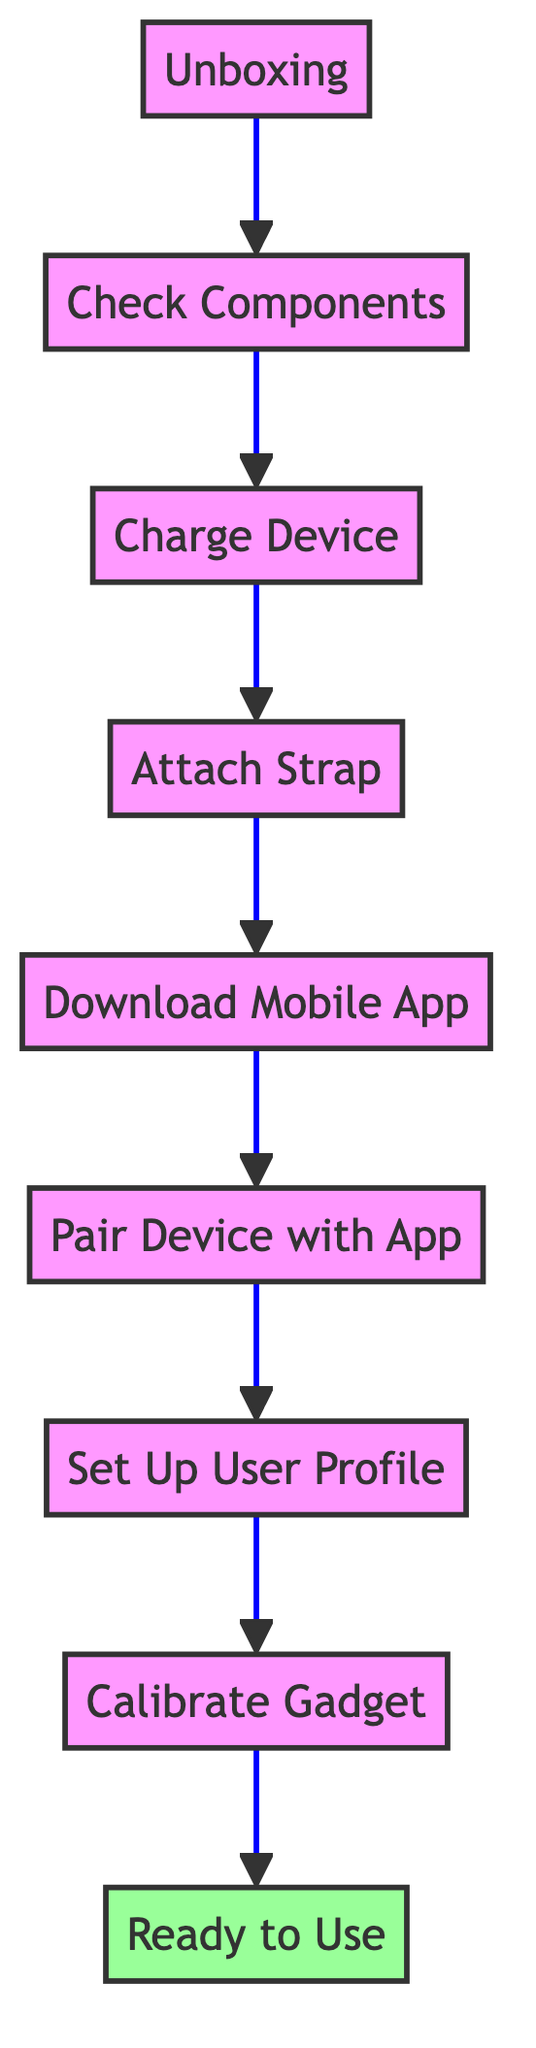What is the first step indicated in the diagram? The diagram shows "Unboxing" as the first step, which is at the bottom of the flow chart.
Answer: Unboxing How many steps are in the assembly and setup process? By counting all the elements in the diagram from "Unboxing" to "Ready to Use", there are a total of nine steps.
Answer: Nine What is the last step before the device is ready to use? The last step before reaching "Ready to Use" is "Calibrate Gadget," which directly precedes it in the flow chart.
Answer: Calibrate Gadget What component should be checked after unboxing? After unboxing, "Check Components" is the next step that specifically involves verifying the presence of all parts included with the Swimming Gadget.
Answer: Check Components What app should be downloaded according to the flowchart? The flow chart specifies downloading the "AquaTech App" from the App Store or Google Play.
Answer: AquaTech App If you want to charge the device, which step would you refer to? The step to charge the device is described as "Charge Device," which comes after checking the components and is the third step in the flow.
Answer: Charge Device What action follows after attaching the strap? Following "Attach Strap," the next step is "Download Mobile App," indicating the sequence of actions in the setup process.
Answer: Download Mobile App What information needs to be provided when setting up your user profile? You need to input details such as height, weight, and swimming skill level during the "Set Up User Profile" process.
Answer: Height, weight, swimming skill level Which step confirms the device is ready for use? The final step titled "Ready to Use" confirms that the device is prepared for the swimming session, making it essential to check settings prior to this step.
Answer: Ready to Use 